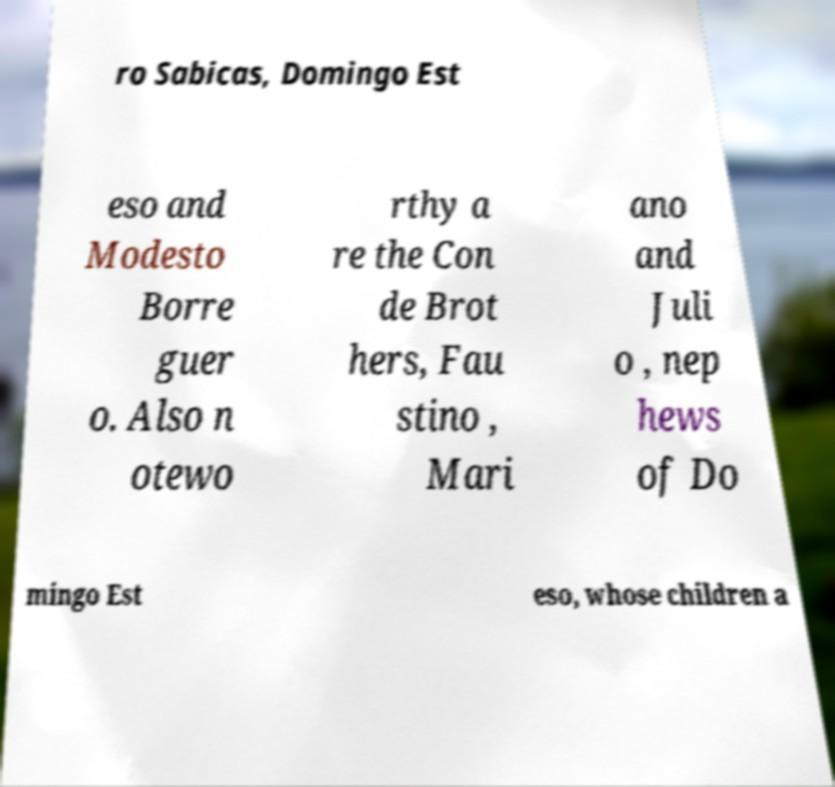For documentation purposes, I need the text within this image transcribed. Could you provide that? ro Sabicas, Domingo Est eso and Modesto Borre guer o. Also n otewo rthy a re the Con de Brot hers, Fau stino , Mari ano and Juli o , nep hews of Do mingo Est eso, whose children a 